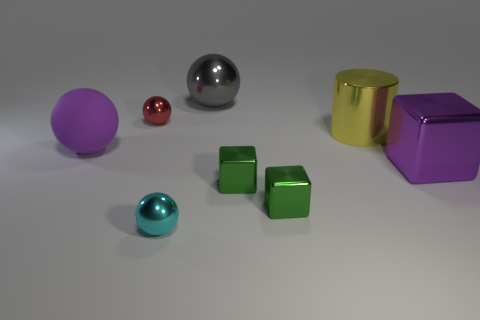There is a metal thing that is on the left side of the ball that is in front of the purple thing that is on the right side of the yellow shiny object; what is its shape?
Your answer should be compact. Sphere. What is the size of the red thing that is the same shape as the small cyan thing?
Your response must be concise. Small. There is a metallic sphere that is both to the right of the small red shiny ball and in front of the gray shiny sphere; what size is it?
Your answer should be very brief. Small. What is the shape of the big metal thing that is the same color as the big rubber thing?
Offer a terse response. Cube. The rubber ball has what color?
Provide a short and direct response. Purple. There is a purple thing that is to the right of the tiny cyan thing; what is its size?
Provide a short and direct response. Large. There is a large shiny object in front of the big sphere that is on the left side of the red metal object; how many big purple metallic cubes are to the right of it?
Offer a terse response. 0. The cylinder that is in front of the big ball that is to the right of the cyan shiny object is what color?
Provide a short and direct response. Yellow. Is there a cyan shiny object that has the same size as the yellow metallic cylinder?
Keep it short and to the point. No. What material is the purple thing that is right of the cyan object that is in front of the small metallic ball that is behind the metallic cylinder?
Give a very brief answer. Metal. 